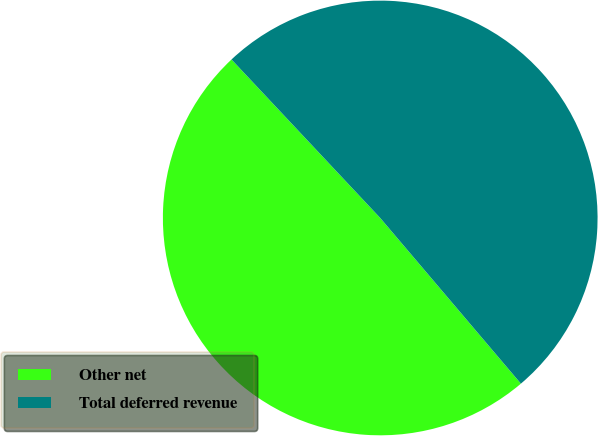<chart> <loc_0><loc_0><loc_500><loc_500><pie_chart><fcel>Other net<fcel>Total deferred revenue<nl><fcel>49.21%<fcel>50.79%<nl></chart> 